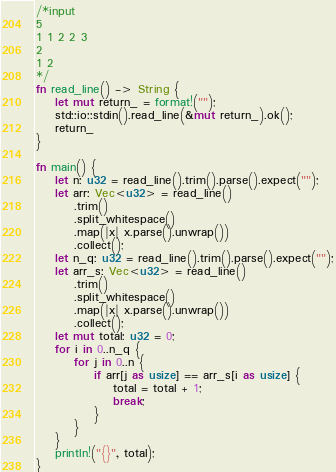Convert code to text. <code><loc_0><loc_0><loc_500><loc_500><_Rust_>/*input
5
1 1 2 2 3
2
1 2
*/
fn read_line() -> String {
    let mut return_ = format!("");
    std::io::stdin().read_line(&mut return_).ok();
    return_
}

fn main() {
    let n: u32 = read_line().trim().parse().expect("");
    let arr: Vec<u32> = read_line()
        .trim()
        .split_whitespace()
        .map(|x| x.parse().unwrap())
        .collect();
    let n_q: u32 = read_line().trim().parse().expect("");
    let arr_s: Vec<u32> = read_line()
        .trim()
        .split_whitespace()
        .map(|x| x.parse().unwrap())
        .collect();
    let mut total: u32 = 0;
    for i in 0..n_q {
        for j in 0..n {
            if arr[j as usize] == arr_s[i as usize] {
                total = total + 1;
                break;
            }
        }
    }
    println!("{}", total);
}

</code> 